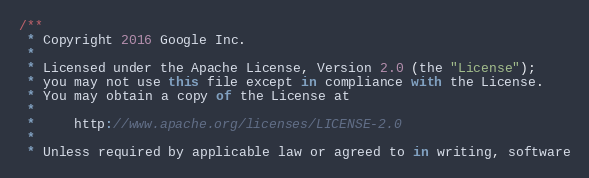<code> <loc_0><loc_0><loc_500><loc_500><_JavaScript_>/**
 * Copyright 2016 Google Inc.
 *
 * Licensed under the Apache License, Version 2.0 (the "License");
 * you may not use this file except in compliance with the License.
 * You may obtain a copy of the License at
 *
 *     http://www.apache.org/licenses/LICENSE-2.0
 *
 * Unless required by applicable law or agreed to in writing, software</code> 